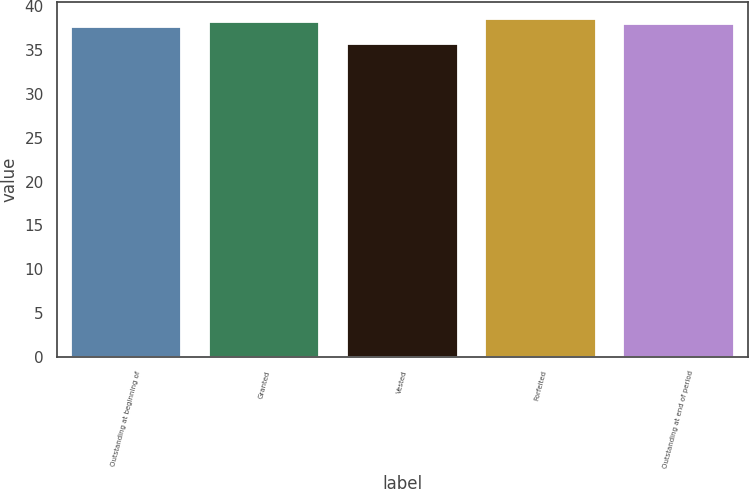<chart> <loc_0><loc_0><loc_500><loc_500><bar_chart><fcel>Outstanding at beginning of<fcel>Granted<fcel>Vested<fcel>Forfeited<fcel>Outstanding at end of period<nl><fcel>37.63<fcel>38.2<fcel>35.66<fcel>38.51<fcel>37.92<nl></chart> 